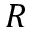<formula> <loc_0><loc_0><loc_500><loc_500>R</formula> 